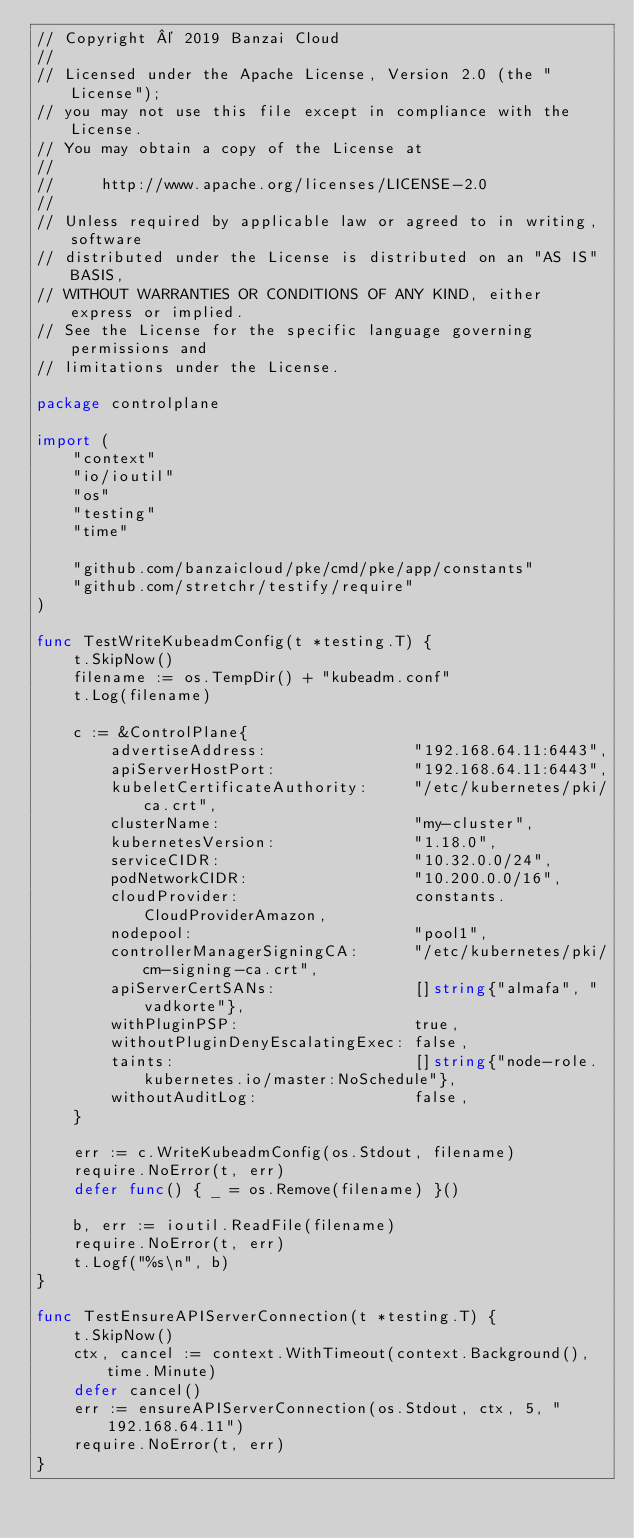<code> <loc_0><loc_0><loc_500><loc_500><_Go_>// Copyright © 2019 Banzai Cloud
//
// Licensed under the Apache License, Version 2.0 (the "License");
// you may not use this file except in compliance with the License.
// You may obtain a copy of the License at
//
//     http://www.apache.org/licenses/LICENSE-2.0
//
// Unless required by applicable law or agreed to in writing, software
// distributed under the License is distributed on an "AS IS" BASIS,
// WITHOUT WARRANTIES OR CONDITIONS OF ANY KIND, either express or implied.
// See the License for the specific language governing permissions and
// limitations under the License.

package controlplane

import (
	"context"
	"io/ioutil"
	"os"
	"testing"
	"time"

	"github.com/banzaicloud/pke/cmd/pke/app/constants"
	"github.com/stretchr/testify/require"
)

func TestWriteKubeadmConfig(t *testing.T) {
	t.SkipNow()
	filename := os.TempDir() + "kubeadm.conf"
	t.Log(filename)

	c := &ControlPlane{
		advertiseAddress:                "192.168.64.11:6443",
		apiServerHostPort:               "192.168.64.11:6443",
		kubeletCertificateAuthority:     "/etc/kubernetes/pki/ca.crt",
		clusterName:                     "my-cluster",
		kubernetesVersion:               "1.18.0",
		serviceCIDR:                     "10.32.0.0/24",
		podNetworkCIDR:                  "10.200.0.0/16",
		cloudProvider:                   constants.CloudProviderAmazon,
		nodepool:                        "pool1",
		controllerManagerSigningCA:      "/etc/kubernetes/pki/cm-signing-ca.crt",
		apiServerCertSANs:               []string{"almafa", "vadkorte"},
		withPluginPSP:                   true,
		withoutPluginDenyEscalatingExec: false,
		taints:                          []string{"node-role.kubernetes.io/master:NoSchedule"},
		withoutAuditLog:                 false,
	}

	err := c.WriteKubeadmConfig(os.Stdout, filename)
	require.NoError(t, err)
	defer func() { _ = os.Remove(filename) }()

	b, err := ioutil.ReadFile(filename)
	require.NoError(t, err)
	t.Logf("%s\n", b)
}

func TestEnsureAPIServerConnection(t *testing.T) {
	t.SkipNow()
	ctx, cancel := context.WithTimeout(context.Background(), time.Minute)
	defer cancel()
	err := ensureAPIServerConnection(os.Stdout, ctx, 5, "192.168.64.11")
	require.NoError(t, err)
}
</code> 